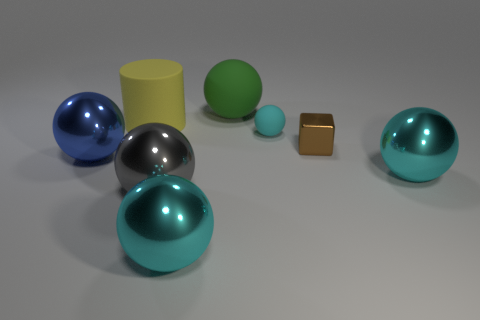What number of large blue shiny things are the same shape as the large yellow rubber object?
Offer a very short reply. 0. Are there any big gray spheres that have the same material as the cylinder?
Ensure brevity in your answer.  No. What material is the large cyan sphere that is to the left of the rubber thing behind the large yellow thing?
Ensure brevity in your answer.  Metal. There is a yellow object on the left side of the green matte sphere; what size is it?
Give a very brief answer. Large. There is a small metal object; is it the same color as the matte sphere that is in front of the yellow cylinder?
Keep it short and to the point. No. Are there any other metallic balls that have the same color as the small ball?
Give a very brief answer. Yes. Does the small brown cube have the same material as the object that is in front of the gray metallic sphere?
Provide a short and direct response. Yes. What number of tiny things are yellow matte cylinders or brown things?
Give a very brief answer. 1. Are there fewer tiny cylinders than small metal cubes?
Your response must be concise. Yes. There is a cyan object that is behind the large blue thing; is its size the same as the cyan shiny object that is on the right side of the tiny cube?
Offer a terse response. No. 